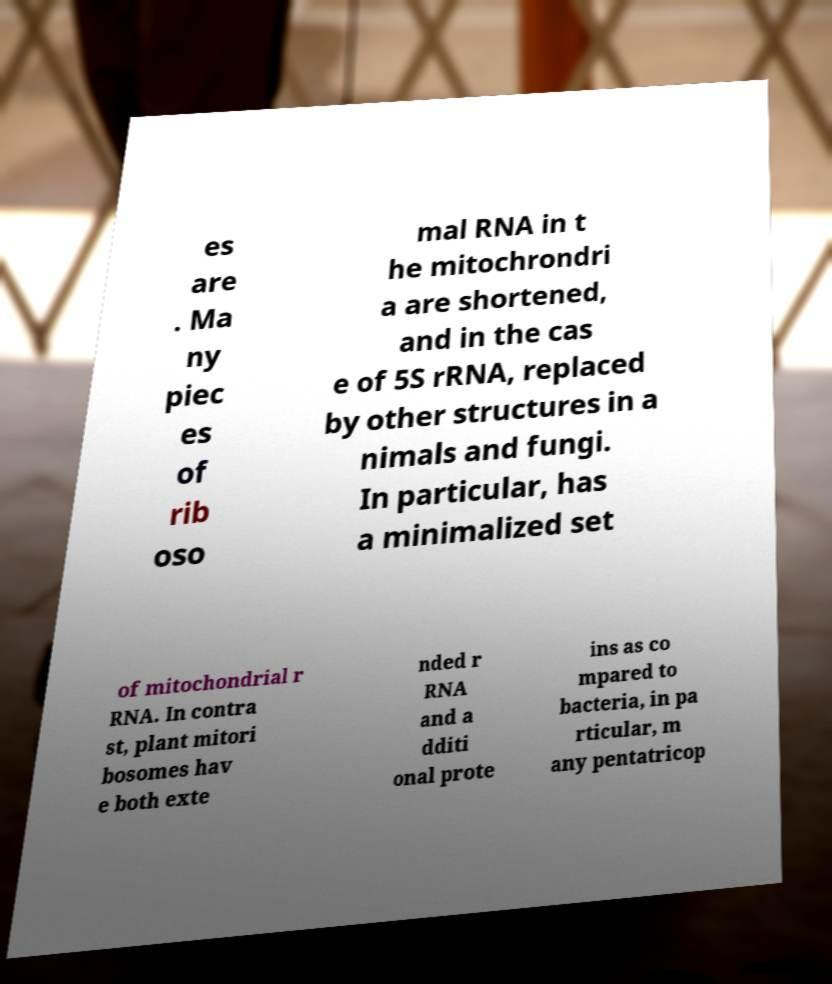I need the written content from this picture converted into text. Can you do that? es are . Ma ny piec es of rib oso mal RNA in t he mitochrondri a are shortened, and in the cas e of 5S rRNA, replaced by other structures in a nimals and fungi. In particular, has a minimalized set of mitochondrial r RNA. In contra st, plant mitori bosomes hav e both exte nded r RNA and a dditi onal prote ins as co mpared to bacteria, in pa rticular, m any pentatricop 